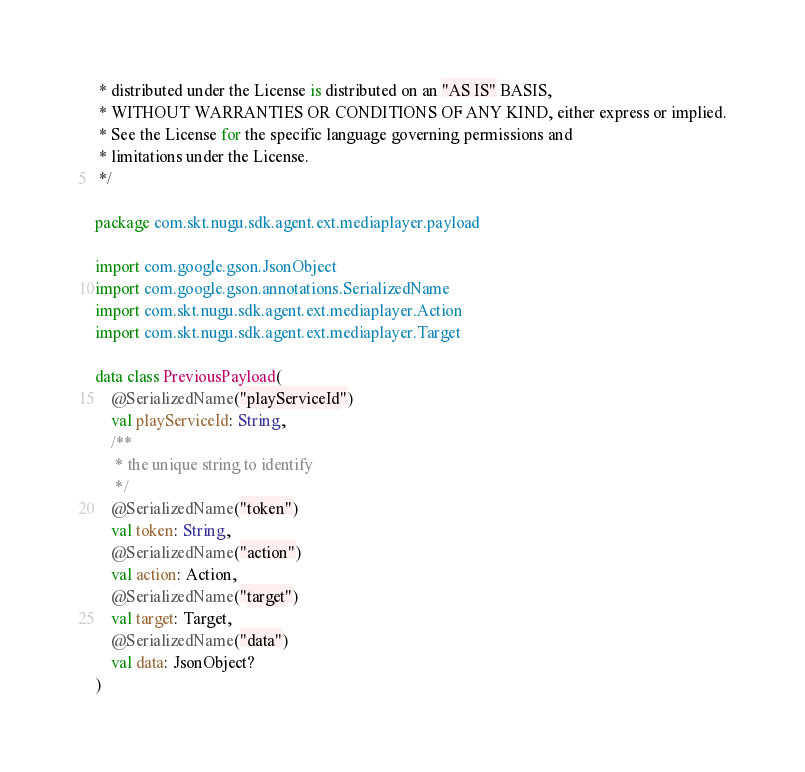Convert code to text. <code><loc_0><loc_0><loc_500><loc_500><_Kotlin_> * distributed under the License is distributed on an "AS IS" BASIS,
 * WITHOUT WARRANTIES OR CONDITIONS OF ANY KIND, either express or implied.
 * See the License for the specific language governing permissions and
 * limitations under the License.
 */

package com.skt.nugu.sdk.agent.ext.mediaplayer.payload

import com.google.gson.JsonObject
import com.google.gson.annotations.SerializedName
import com.skt.nugu.sdk.agent.ext.mediaplayer.Action
import com.skt.nugu.sdk.agent.ext.mediaplayer.Target

data class PreviousPayload(
    @SerializedName("playServiceId")
    val playServiceId: String,
    /**
     * the unique string to identify
     */
    @SerializedName("token")
    val token: String,
    @SerializedName("action")
    val action: Action,
    @SerializedName("target")
    val target: Target,
    @SerializedName("data")
    val data: JsonObject?
)</code> 